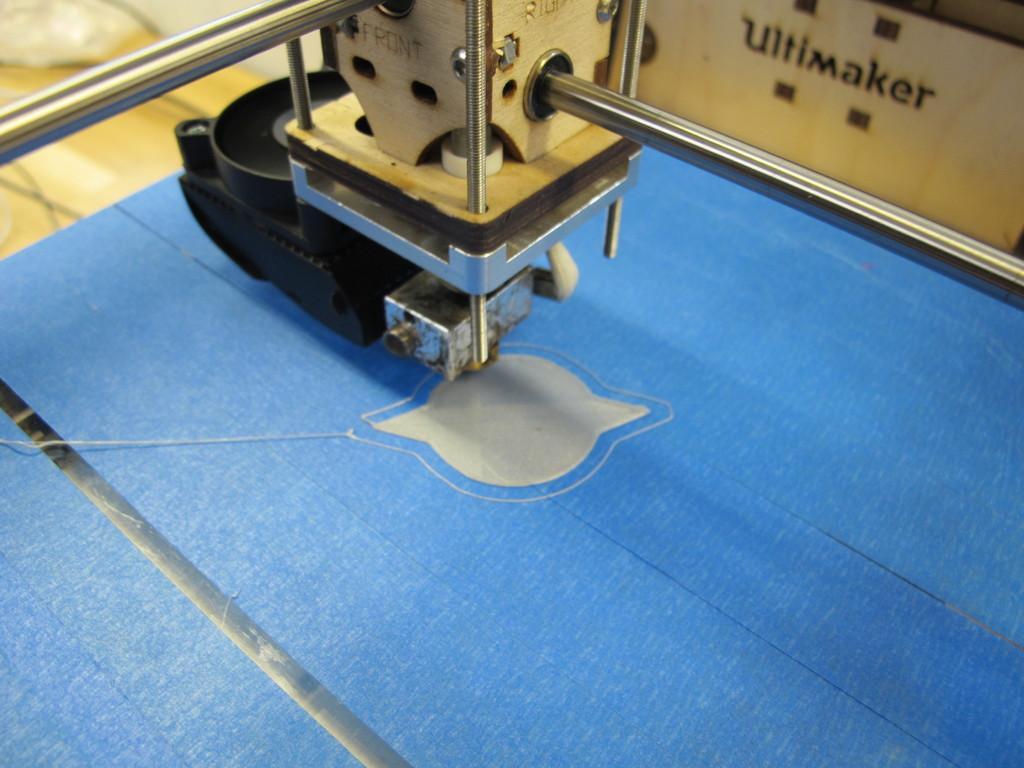Could you give a brief overview of what you see in this image? In this picture there is a machine. At the bottom it looks like a sheet. At the back there is a box and there is text on the box and there are wires. 